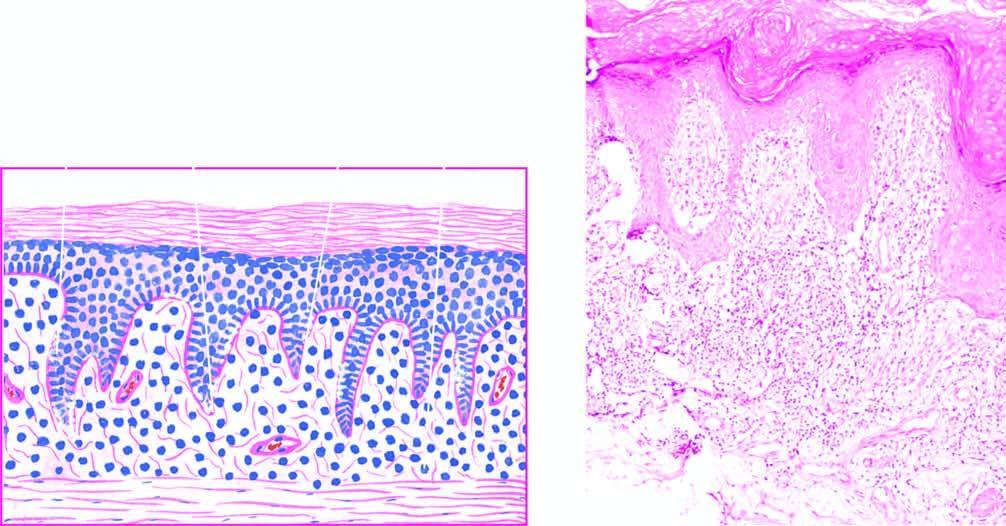what does the upper dermis show?
Answer the question using a single word or phrase. A band-like mononuclear infiltrate with a sharply-demarcated lower border 